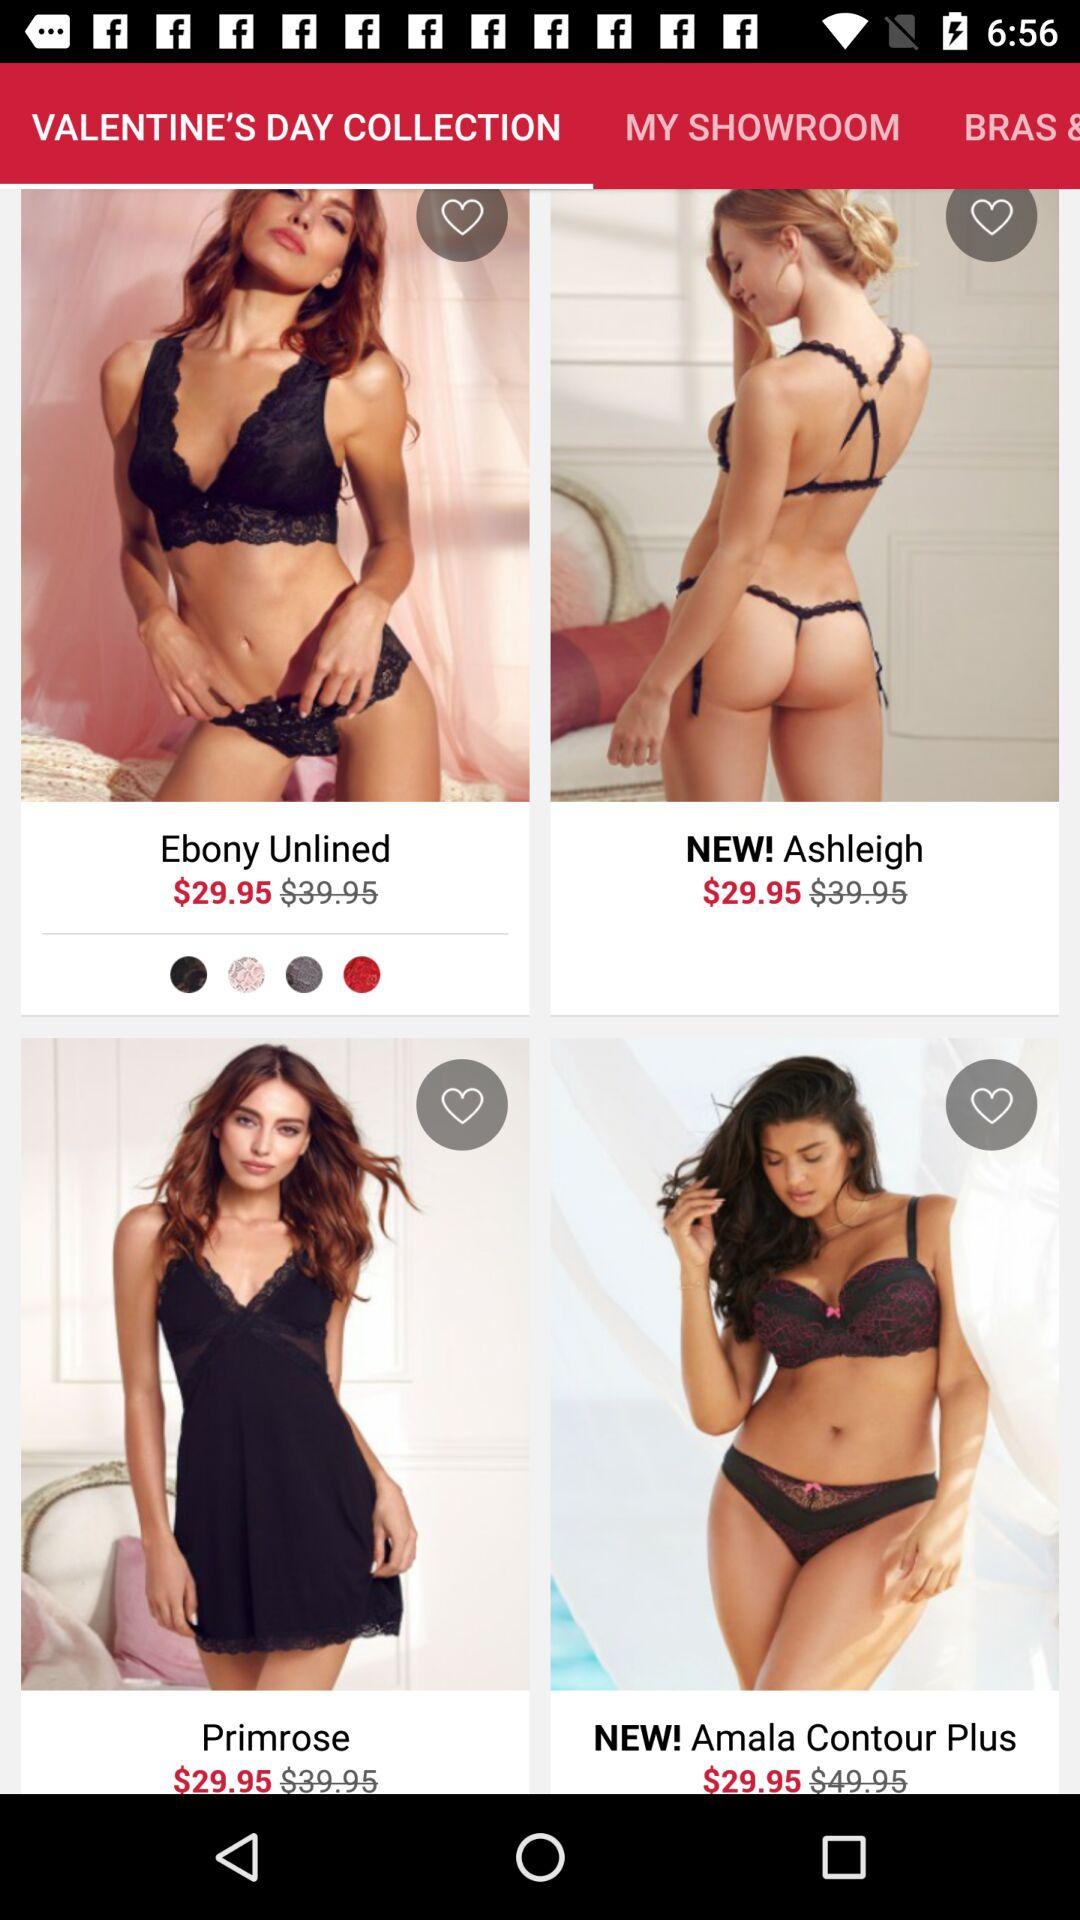How many items are in "MY SHOWROOM"?
When the provided information is insufficient, respond with <no answer>. <no answer> 